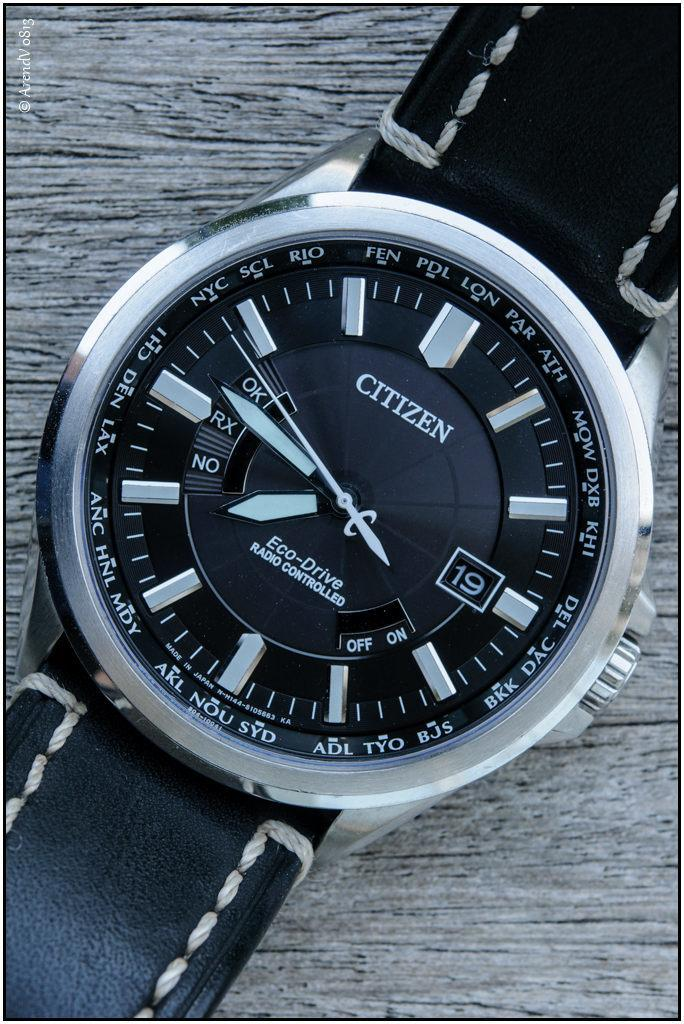What object is the main focus of the image? There is a wrist watch in the image. What color is the wrist watch? The wrist watch is black in color. Where is the wrist watch located in the image? The wrist watch is on a surface. Is there a woman wearing the wrist watch in the image? There is no woman present in the image, only the wrist watch on a surface. What type of badge can be seen on the wrist watch in the image? There is no badge present on the wrist watch in the image; it is simply a black wrist watch on a surface. 